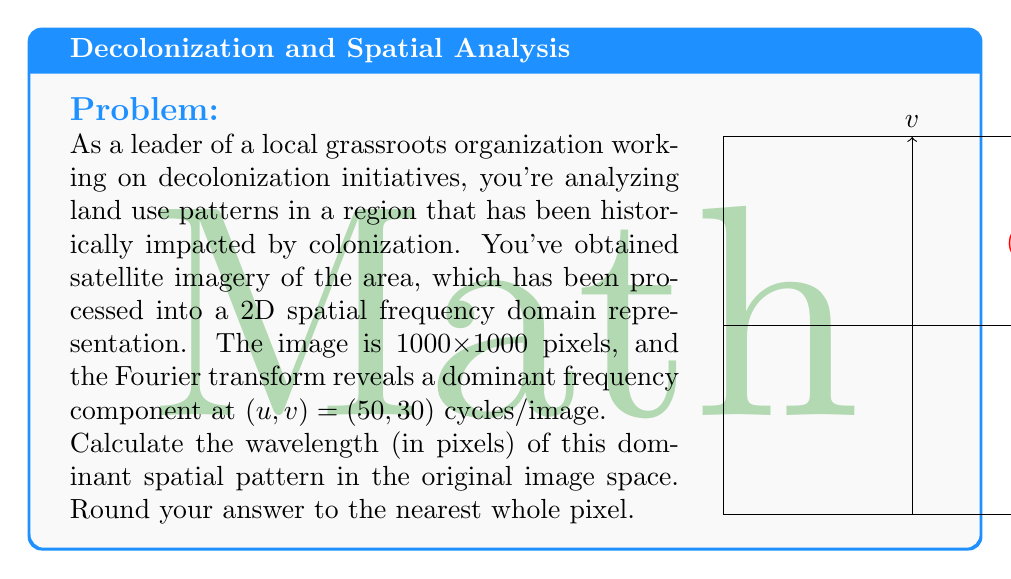Give your solution to this math problem. To solve this problem, we need to follow these steps:

1) In the Fourier domain, the frequency components are represented as (u, v) pairs, where u and v are the horizontal and vertical frequency components respectively.

2) The given frequency component is (50, 30) cycles/image.

3) To find the wavelength, we need to calculate the magnitude of this frequency vector:

   $$f = \sqrt{u^2 + v^2} = \sqrt{50^2 + 30^2} = \sqrt{2500 + 900} = \sqrt{3400} \approx 58.31 \text{ cycles/image}$$

4) The wavelength is the inverse of the frequency. Given that the image is 1000x1000 pixels, we can calculate the wavelength in pixels:

   $$\lambda = \frac{\text{image size}}{f} = \frac{1000}{58.31} \approx 17.15 \text{ pixels}$$

5) Rounding to the nearest whole pixel:

   $$\lambda \approx 17 \text{ pixels}$$

This wavelength represents the dominant spatial pattern in the original image, which could correspond to recurring land use patterns or resource distribution in the analyzed region.
Answer: 17 pixels 